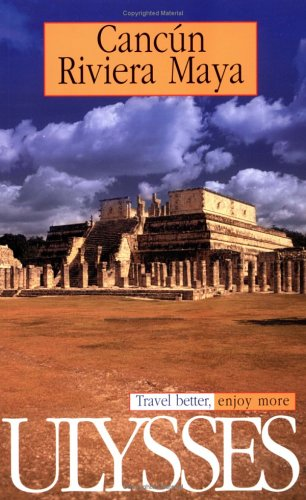Is this book related to Travel? Yes, this book is indeed related to travel, aiming to provide readers with valuable insights and information about traveling in Cancun and Riviera Maya. 